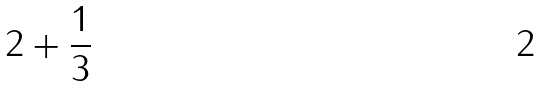Convert formula to latex. <formula><loc_0><loc_0><loc_500><loc_500>2 + \frac { 1 } { 3 }</formula> 